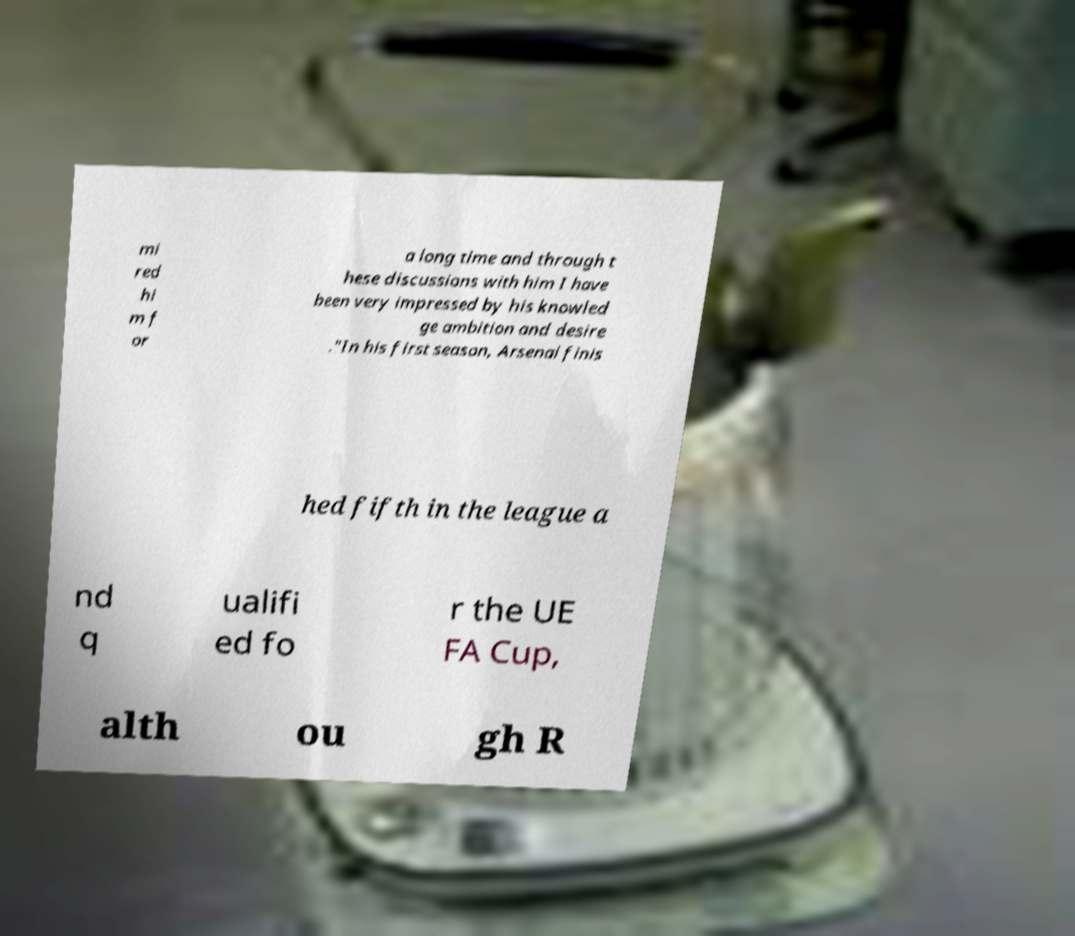For documentation purposes, I need the text within this image transcribed. Could you provide that? mi red hi m f or a long time and through t hese discussions with him I have been very impressed by his knowled ge ambition and desire ."In his first season, Arsenal finis hed fifth in the league a nd q ualifi ed fo r the UE FA Cup, alth ou gh R 